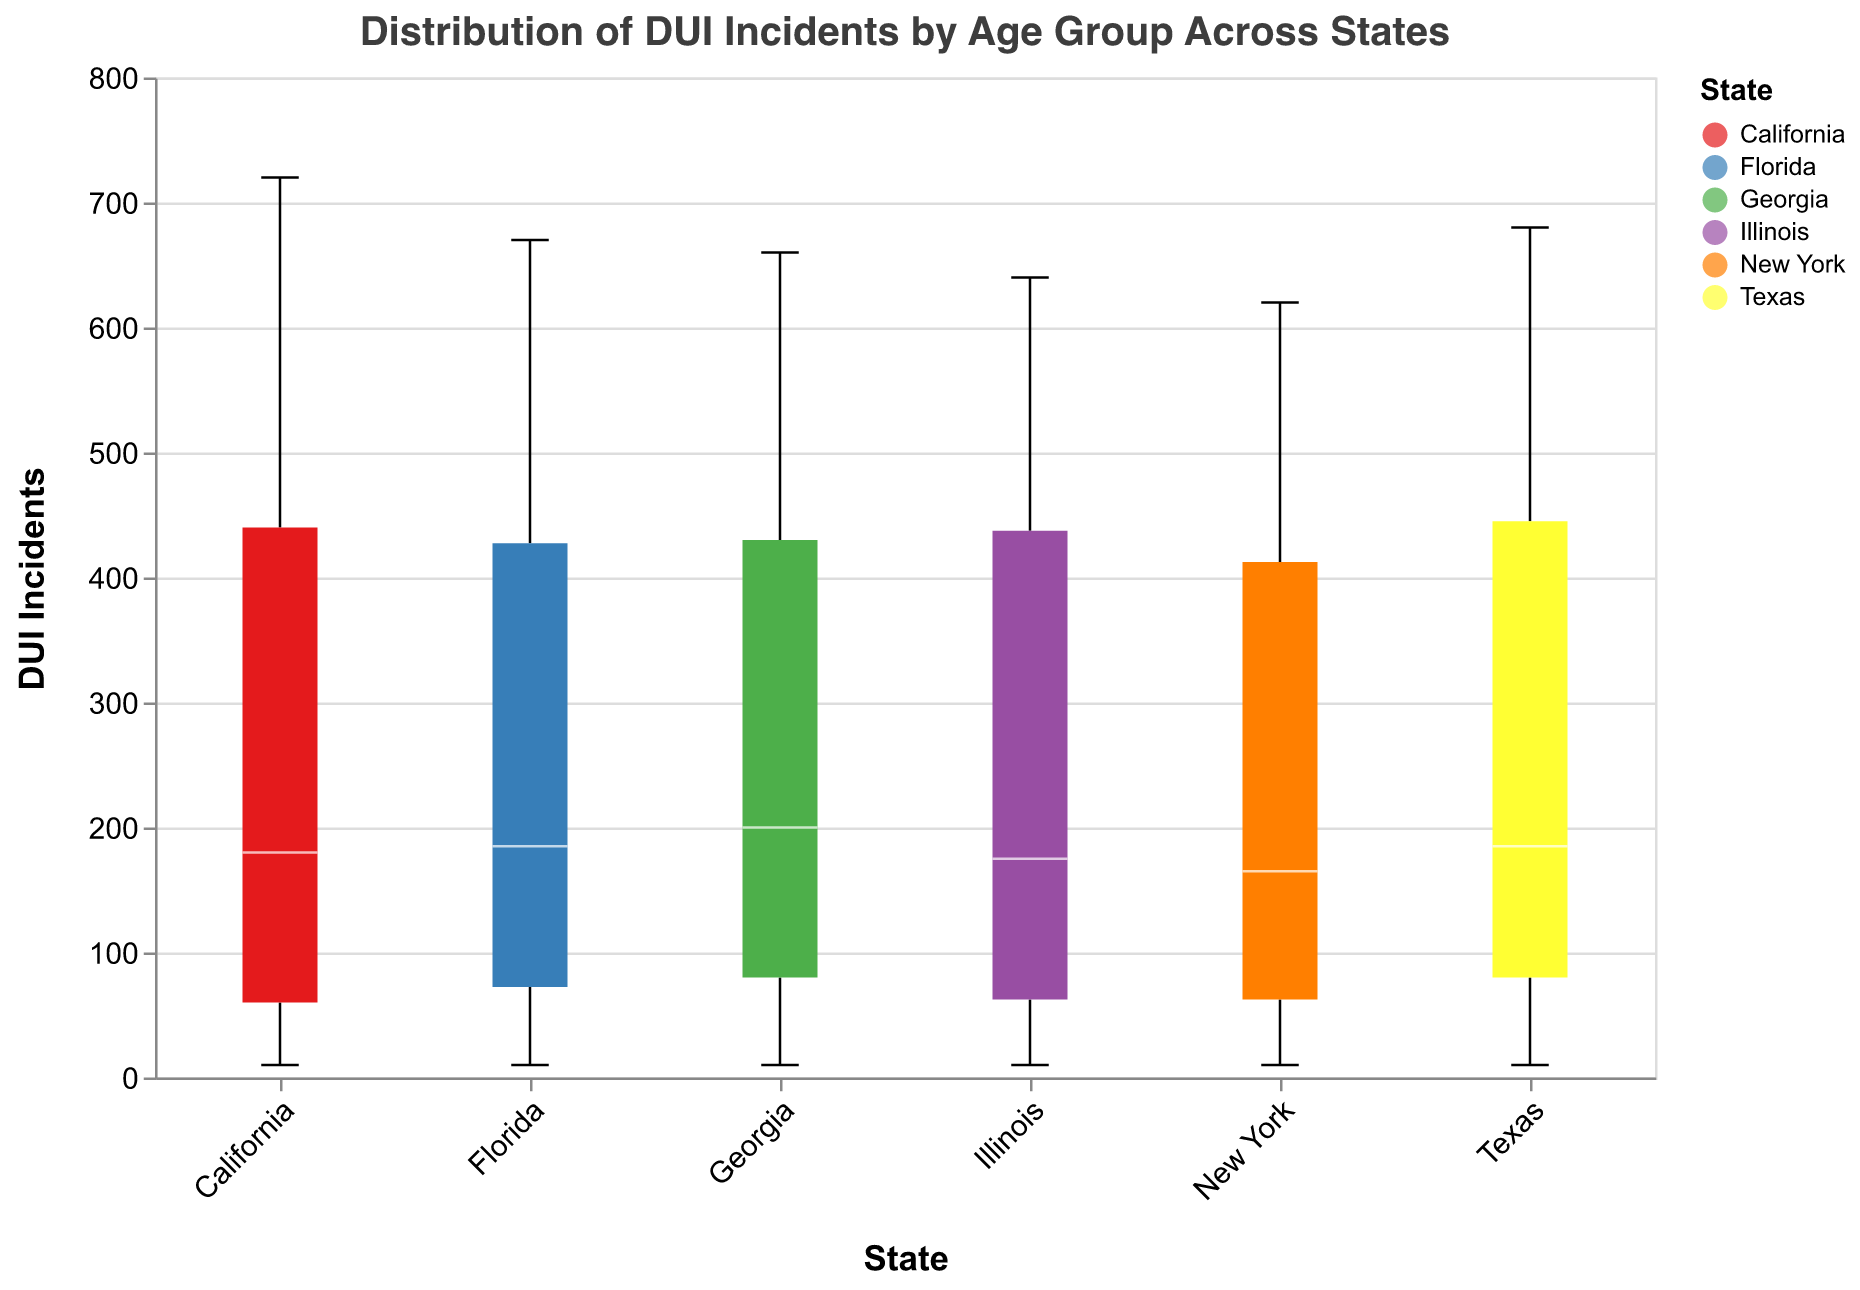What does the title of the figure indicate? The title provides an overview of what the figure is representing, which is the distribution of DUI incidents by age group across various states
Answer: Distribution of DUI Incidents by Age Group Across States Which state has the highest median number of DUI incidents? By examining the medians on the boxplot, the state with the highest median value can be identified. This corresponds to the line inside the box that is positioned highest on the y-axis.
Answer: California What is the interquartile range (IQR) for DUI incidents in Texas? The IQR can be determined by measuring the range between the first (lower) quartile and the third (upper) quartile values of the box for Texas
Answer: Approx. 130 Which state shows the smallest range (difference between minimum and maximum) of DUI incidents across age groups? The range is the difference between the smallest and largest data points. The state with the smallest difference will have the narrowest boxplot extent.
Answer: Georgia Which age group has the highest number of DUI incidents in New York? Identify the data point that represents the highest peak on the boxplot for New York and see which age group it corresponds to.
Answer: 21-25 Compare the median number of DUI incidents between California and New York. Which state has a higher median? The median is indicated by the line within each box. The state with the line higher up on the y-axis has a higher median
Answer: California How does the distribution of DUI incidents in the 16-20 age group in Florida compare to that in Illinois? Look at the spread, median, and range of the boxplots for 16-20 age group in both states. Florida has higher DUI incidents compared to Illinois, which can be deduced by comparing the positions and lengths of the boxes
Answer: Florida has higher DUI incidents Are there any outliers detected in Georgia's data? Outliers are shown as points outside the whiskers of the boxplot. Check if Georgia has points that fall outside the range of the whiskers.
Answer: No outliers Which state’s data has the greatest overall variability in DUI incidents? The state with the widest range between the smallest and largest whiskers indicates the greatest variability.
Answer: California Which state has a higher proportion of DUI incidents in younger age groups (16-25)? Examine the values within the 16-20 and 21-25 age groups for each state. Aggregate the values and compare them across all states.
Answer: California 